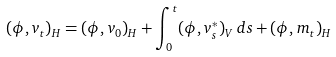Convert formula to latex. <formula><loc_0><loc_0><loc_500><loc_500>( \phi , v _ { t } ) _ { H } = ( \phi , v _ { 0 } ) _ { H } + \int _ { 0 } ^ { t } ( \phi , v ^ { * } _ { s } ) _ { V } \, d s + ( \phi , m _ { t } ) _ { H }</formula> 